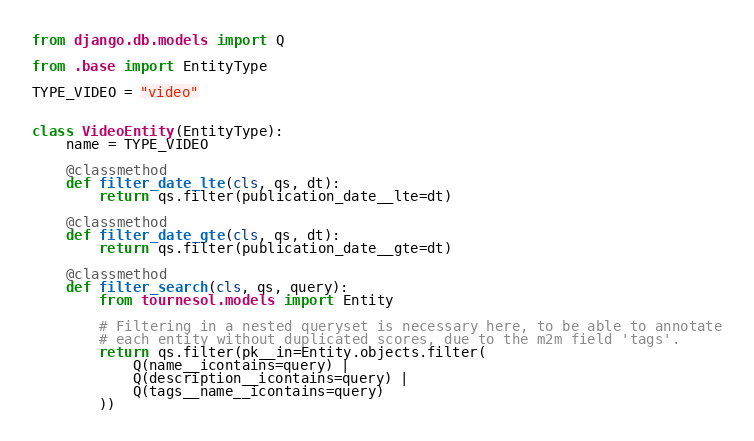<code> <loc_0><loc_0><loc_500><loc_500><_Python_>from django.db.models import Q

from .base import EntityType

TYPE_VIDEO = "video"


class VideoEntity(EntityType):
    name = TYPE_VIDEO

    @classmethod
    def filter_date_lte(cls, qs, dt):
        return qs.filter(publication_date__lte=dt)

    @classmethod
    def filter_date_gte(cls, qs, dt):
        return qs.filter(publication_date__gte=dt)

    @classmethod
    def filter_search(cls, qs, query):
        from tournesol.models import Entity

        # Filtering in a nested queryset is necessary here, to be able to annotate
        # each entity without duplicated scores, due to the m2m field 'tags'.
        return qs.filter(pk__in=Entity.objects.filter(
            Q(name__icontains=query) |
            Q(description__icontains=query) |
            Q(tags__name__icontains=query)
        ))
</code> 